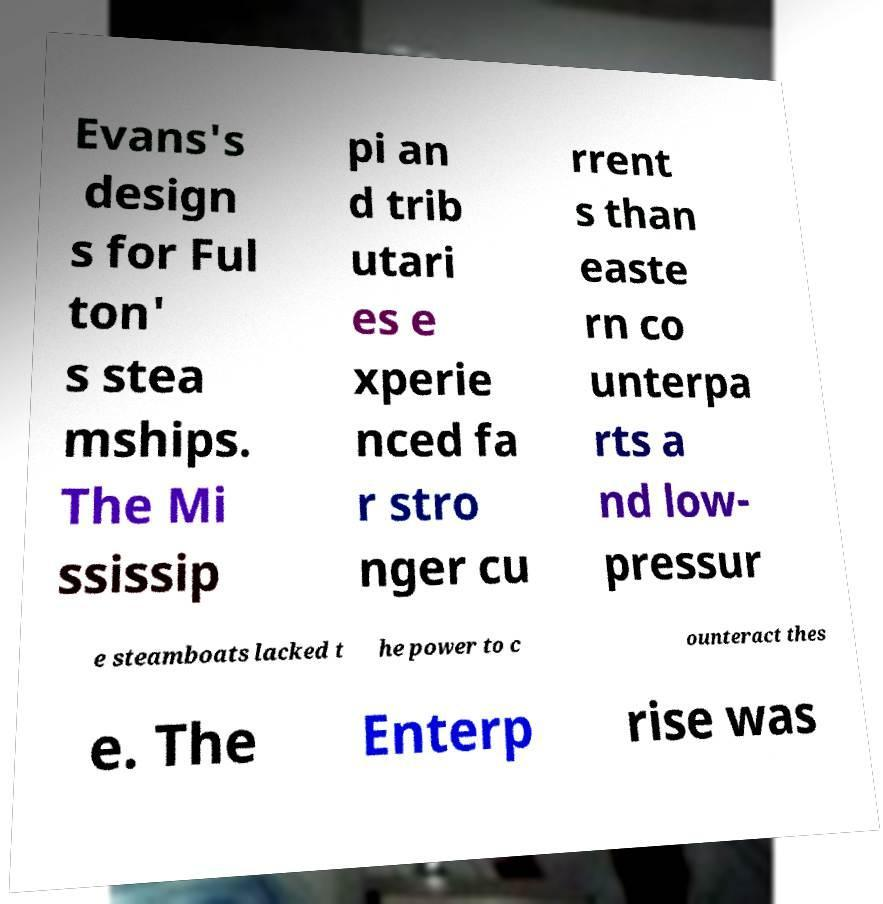Can you read and provide the text displayed in the image?This photo seems to have some interesting text. Can you extract and type it out for me? Evans's design s for Ful ton' s stea mships. The Mi ssissip pi an d trib utari es e xperie nced fa r stro nger cu rrent s than easte rn co unterpa rts a nd low- pressur e steamboats lacked t he power to c ounteract thes e. The Enterp rise was 